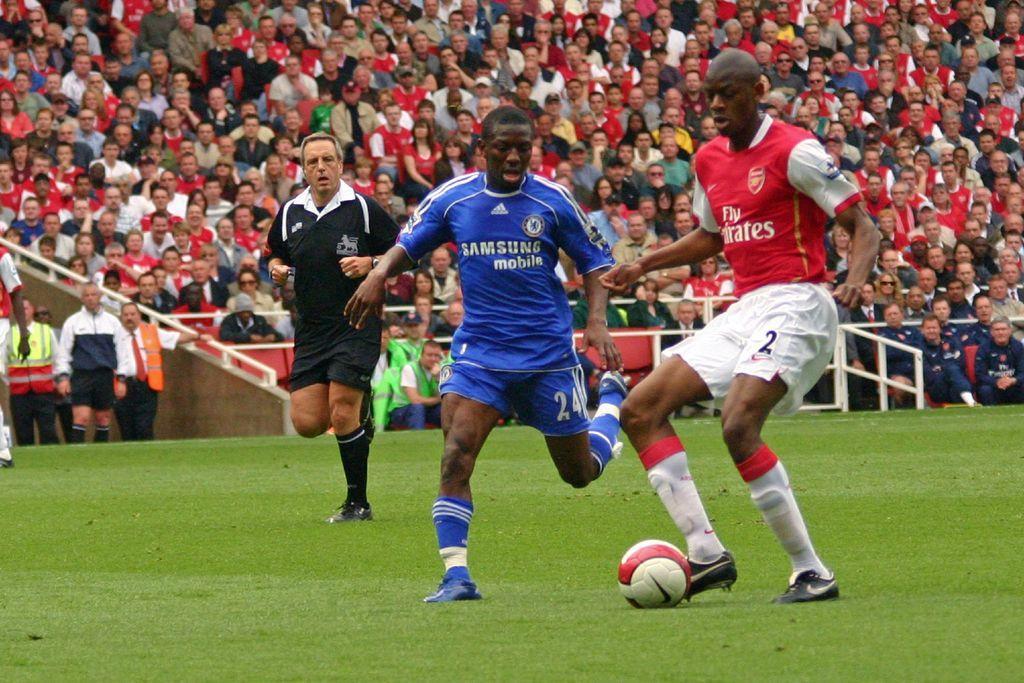In one or two sentences, can you explain what this image depicts? In this image I can see a group of people among them, few are playing football and other people are sitting on a chair. I can also see there is a ball on the ground. 